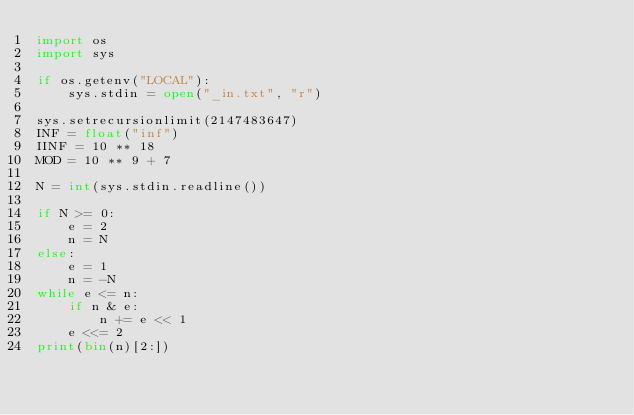<code> <loc_0><loc_0><loc_500><loc_500><_Python_>import os
import sys

if os.getenv("LOCAL"):
    sys.stdin = open("_in.txt", "r")

sys.setrecursionlimit(2147483647)
INF = float("inf")
IINF = 10 ** 18
MOD = 10 ** 9 + 7

N = int(sys.stdin.readline())

if N >= 0:
    e = 2
    n = N
else:
    e = 1
    n = -N
while e <= n:
    if n & e:
        n += e << 1
    e <<= 2
print(bin(n)[2:])
</code> 